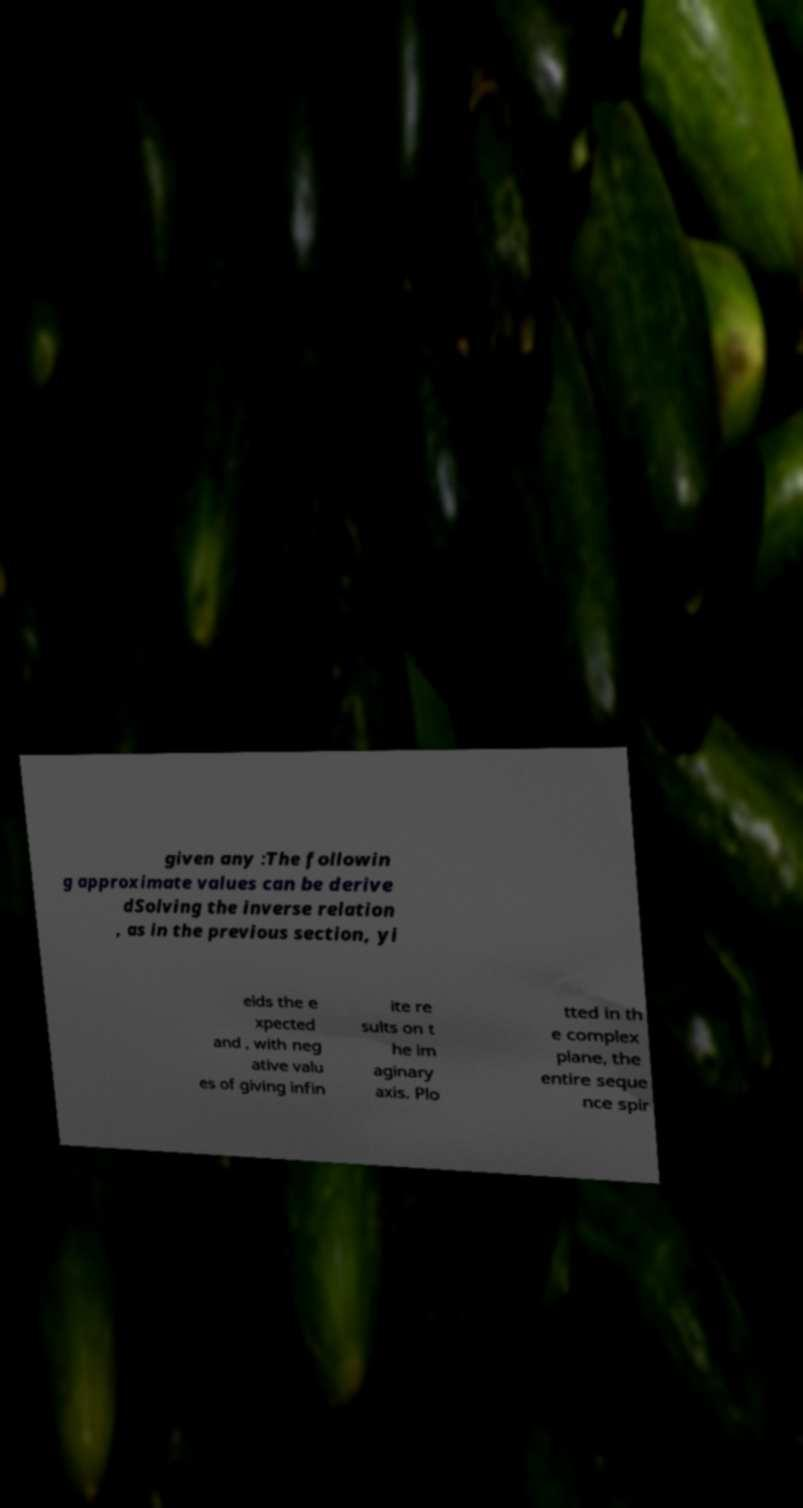Can you read and provide the text displayed in the image?This photo seems to have some interesting text. Can you extract and type it out for me? given any :The followin g approximate values can be derive dSolving the inverse relation , as in the previous section, yi elds the e xpected and , with neg ative valu es of giving infin ite re sults on t he im aginary axis. Plo tted in th e complex plane, the entire seque nce spir 